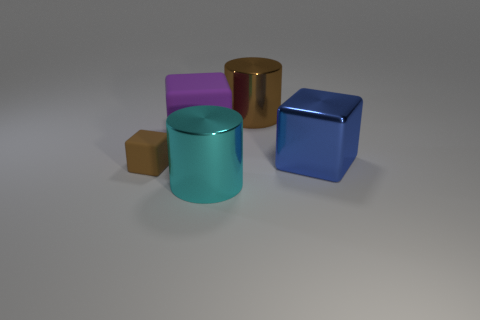What material do the objects appear to be made out of? Based on the image, the objects seem to have different materials. The brown cube looks like it might be made of a rubber or matte substance, while the gold and blue cubes have a reflective surface, indicating a metallic or plastic material. The purple and teal objects have a smoother, more satin-like finish that could suggest a ceramic or plastic material. 